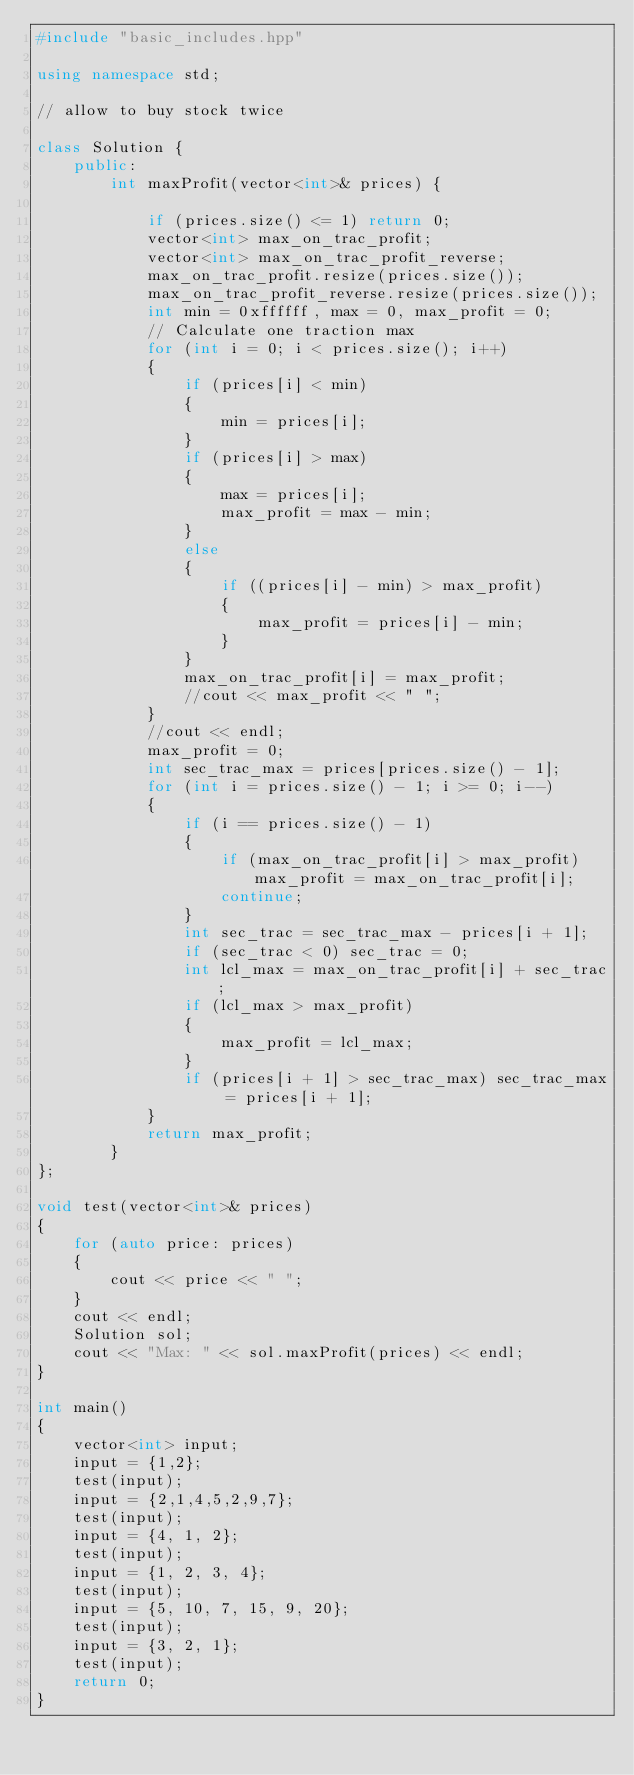Convert code to text. <code><loc_0><loc_0><loc_500><loc_500><_C++_>#include "basic_includes.hpp"

using namespace std;

// allow to buy stock twice

class Solution {
    public:
        int maxProfit(vector<int>& prices) {

            if (prices.size() <= 1) return 0;
            vector<int> max_on_trac_profit;
            vector<int> max_on_trac_profit_reverse;
            max_on_trac_profit.resize(prices.size());
            max_on_trac_profit_reverse.resize(prices.size());
            int min = 0xffffff, max = 0, max_profit = 0;
            // Calculate one traction max
            for (int i = 0; i < prices.size(); i++)
            {
                if (prices[i] < min)
                {
                    min = prices[i];
                }
                if (prices[i] > max)
                {
                    max = prices[i];
                    max_profit = max - min;
                }
                else
                {
                    if ((prices[i] - min) > max_profit)
                    {
                        max_profit = prices[i] - min;
                    }
                }
                max_on_trac_profit[i] = max_profit;
                //cout << max_profit << " ";
            }
            //cout << endl;
            max_profit = 0;
            int sec_trac_max = prices[prices.size() - 1];
            for (int i = prices.size() - 1; i >= 0; i--)
            {
                if (i == prices.size() - 1)
                {
                    if (max_on_trac_profit[i] > max_profit) max_profit = max_on_trac_profit[i];
                    continue;
                }
                int sec_trac = sec_trac_max - prices[i + 1];
                if (sec_trac < 0) sec_trac = 0;
                int lcl_max = max_on_trac_profit[i] + sec_trac;
                if (lcl_max > max_profit)
                {
                    max_profit = lcl_max;
                }
                if (prices[i + 1] > sec_trac_max) sec_trac_max = prices[i + 1];
            }
            return max_profit;
        }
};

void test(vector<int>& prices)
{
    for (auto price: prices)
    {
        cout << price << " ";
    }
    cout << endl;
    Solution sol;
    cout << "Max: " << sol.maxProfit(prices) << endl;
}

int main()
{
    vector<int> input;
    input = {1,2};
    test(input);
    input = {2,1,4,5,2,9,7};
    test(input);
    input = {4, 1, 2};
    test(input);
    input = {1, 2, 3, 4};
    test(input);
    input = {5, 10, 7, 15, 9, 20};
    test(input);
    input = {3, 2, 1};
    test(input);
    return 0;
}
</code> 